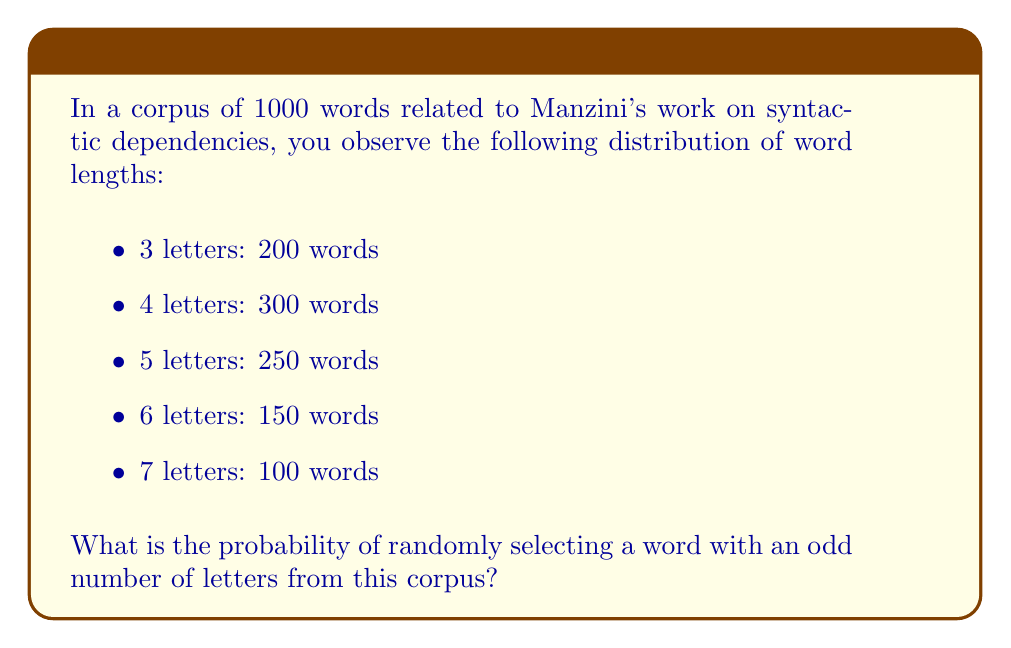Could you help me with this problem? Let's approach this step-by-step:

1. Identify words with odd number of letters:
   - 3 letters: 200 words
   - 5 letters: 250 words
   - 7 letters: 100 words

2. Calculate the total number of words with odd number of letters:
   $200 + 250 + 100 = 550$ words

3. Calculate the probability using the formula:
   $$P(\text{odd number of letters}) = \frac{\text{number of favorable outcomes}}{\text{total number of possible outcomes}}$$

4. Substitute the values:
   $$P(\text{odd number of letters}) = \frac{550}{1000}$$

5. Simplify the fraction:
   $$P(\text{odd number of letters}) = \frac{11}{20} = 0.55$$

Therefore, the probability of randomly selecting a word with an odd number of letters from this corpus is $\frac{11}{20}$ or 0.55 or 55%.
Answer: $\frac{11}{20}$ 